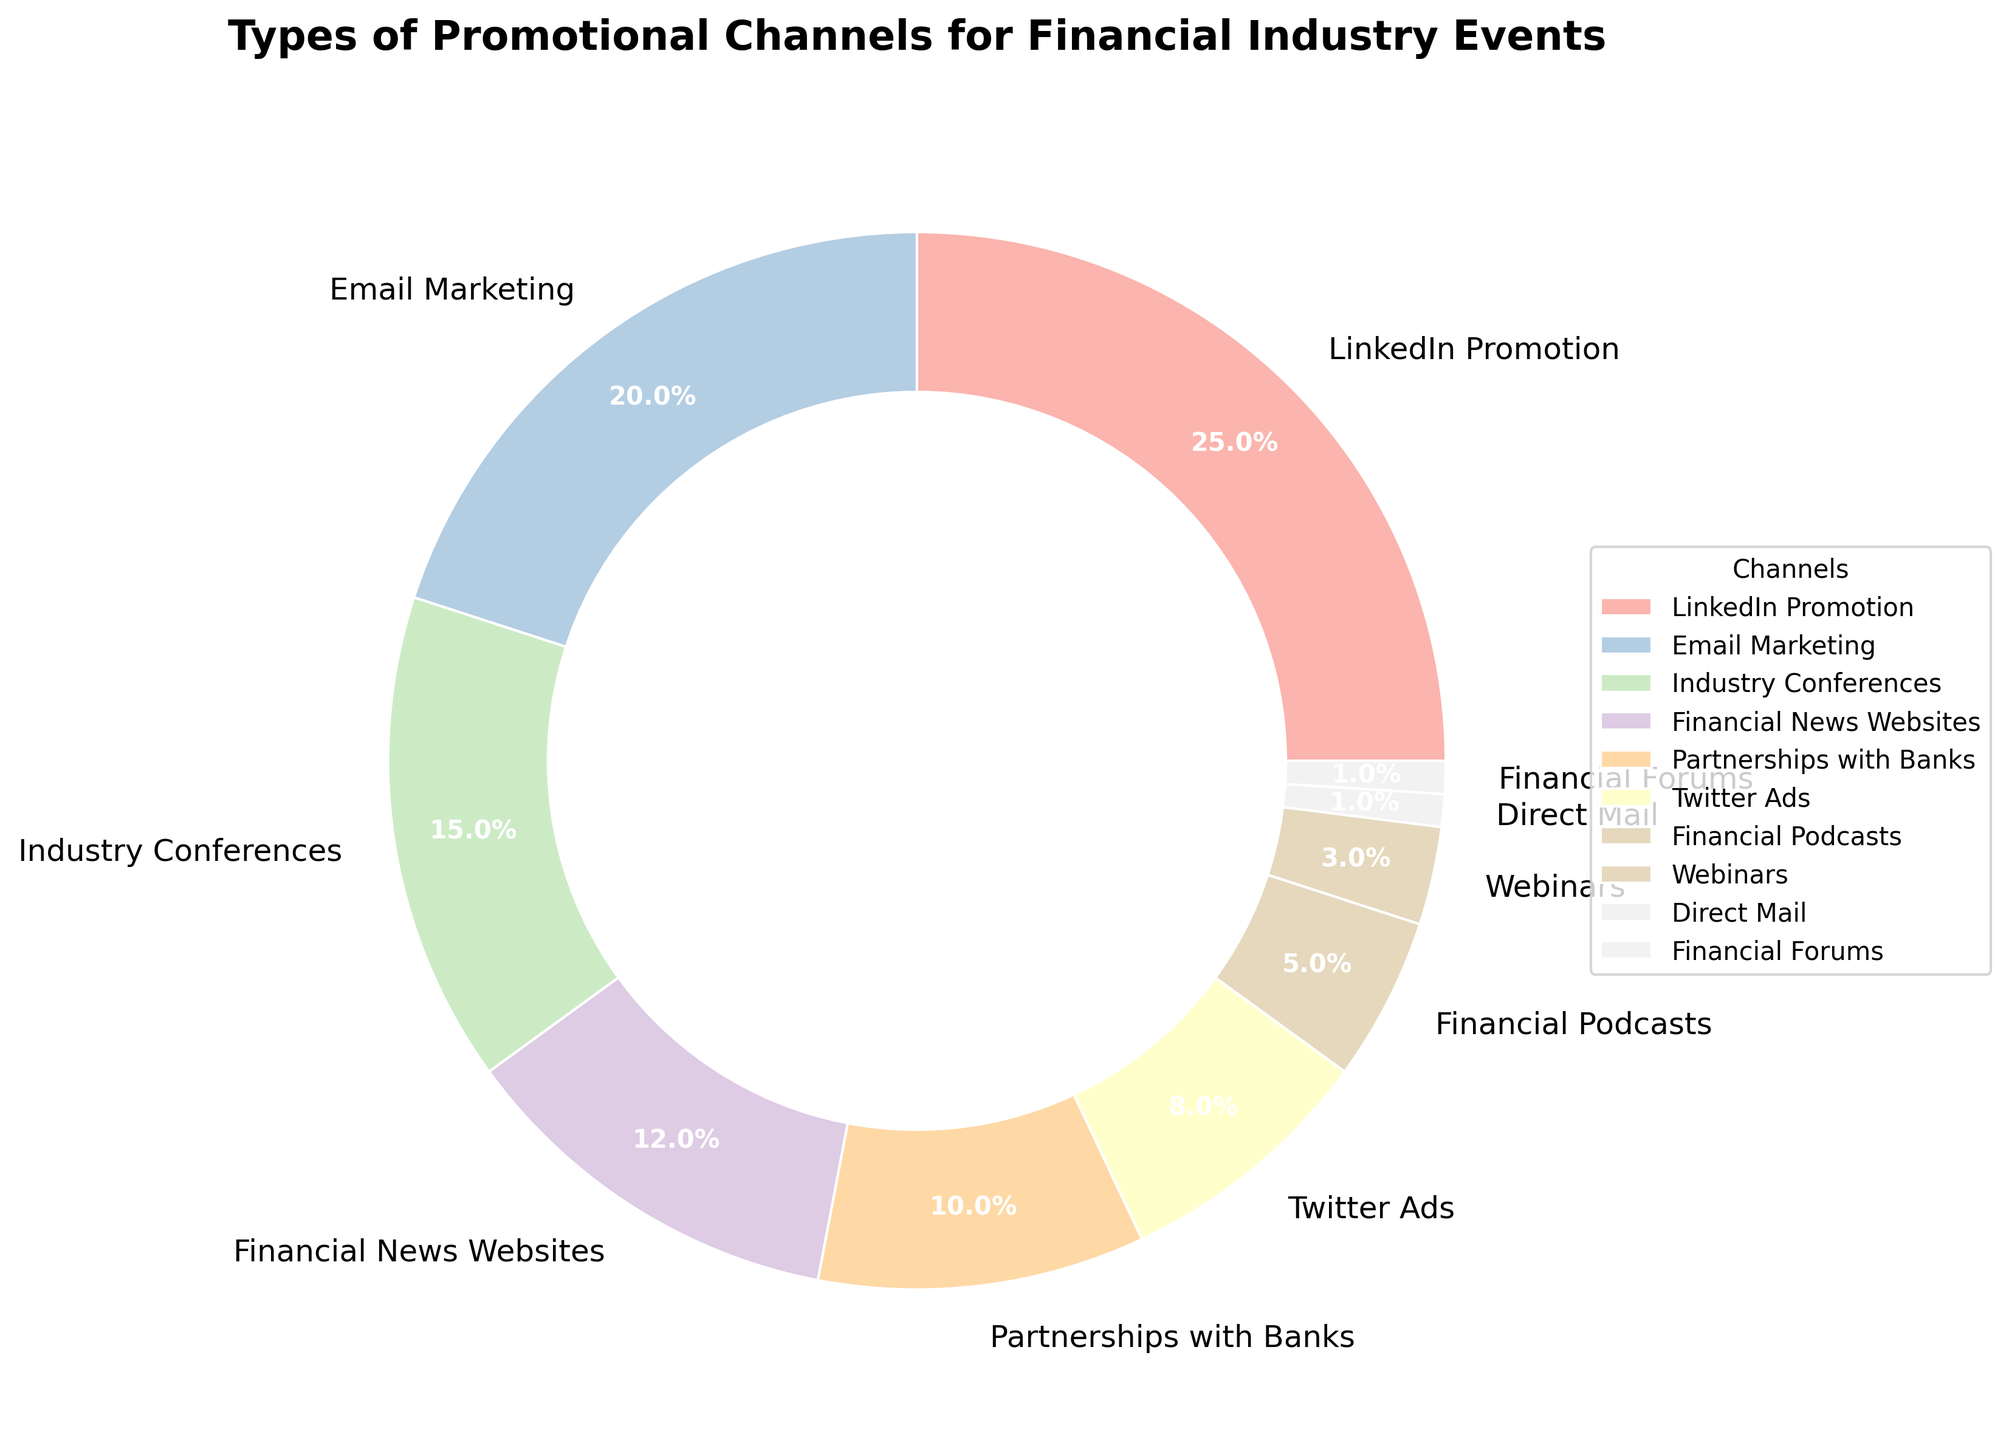What percentage of promotional channels combined is covered by LinkedIn Promotion and Email Marketing? To find the combined percentage, add the percentage of LinkedIn Promotion (25%) and Email Marketing (20%): 25 + 20 = 45.
Answer: 45% How much more popular is LinkedIn Promotion compared to Twitter Ads? Subtract the percentage of Twitter Ads (8%) from LinkedIn Promotion (25%): 25 - 8 = 17.
Answer: 17% Which promotional channel has the lowest usage percentage, and what is it? Both Direct Mail and Financial Forums have the lowest usage percentage, each at 1%.
Answer: Direct Mail and Financial Forums, 1% Is the usage of Webinars higher than Financial Podcasts? Webinars have a usage percentage of 3%, while Financial Podcasts are at 5%. 3% is less than 5%.
Answer: No What is the total percentage of channels not used for digital promotions? Identify non-digital channels: Industry Conferences (15%) and Direct Mail (1%). Add their percentages: 15 + 1 = 16.
Answer: 16% Which channel in the top three has the second highest usage percentage? The top three channels are LinkedIn Promotion (25%), Email Marketing (20%), and Industry Conferences (15%). The second highest is Email Marketing at 20%.
Answer: Email Marketing, 20% How many more times is LinkedIn Promotion used compared to Direct Mail? LinkedIn Promotion (25%) divided by Direct Mail (1%) equals 25. So, LinkedIn Promotion is used 25 times more than Direct Mail.
Answer: 25 times Does Financial News Websites have a greater or equal percentage compared to the sum of Twitter Ads and Financial Podcasts? Financial News Websites have a 12% share. The sum of Twitter Ads (8%) and Financial Podcasts (5%) is 13%. 12% is less than 13%.
Answer: Less What is the total percentage accounted for by the channels used less than 10%? Identify channels with less than 10%: Twitter Ads (8%), Financial Podcasts (5%), Webinars (3%), Direct Mail (1%), and Financial Forums (1%). Add their percentages: 8 + 5 + 3 + 1 + 1 = 18.
Answer: 18% What percentage of the promotional channels is dedicated to social media platforms? Social media platforms are LinkedIn Promotion (25%) and Twitter Ads (8%). Add their percentages: 25 + 8 = 33.
Answer: 33% 